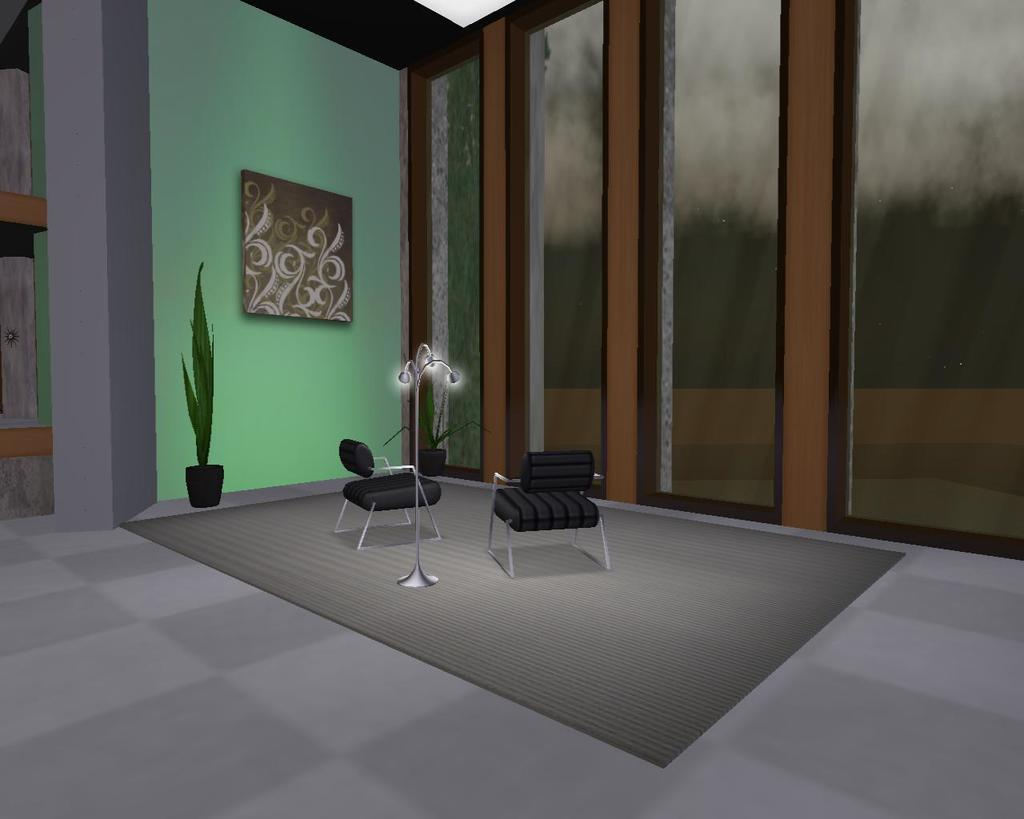What type of image is being described? The image is animated. What type of furniture can be seen in the image? There are chairs in the image. What is the stand with lights placed on? The stand with lights is on a mat. What is hanging on the wall in the image? There is a wall with a frame in the image. What type of plant is present in the image? There is a pot with a plant in the image. What type of stocking is being worn by the laborer in the image? There are no laborers or stockings present in the image. What type of furniture is being used by the furniture maker in the image? There is no furniture maker or furniture-making activity depicted in the image. 